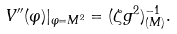<formula> <loc_0><loc_0><loc_500><loc_500>V ^ { \prime \prime } ( \varphi ) | _ { \varphi = M ^ { 2 } } = ( \zeta g ^ { 2 } ) ^ { - 1 } _ { ( M ) } .</formula> 